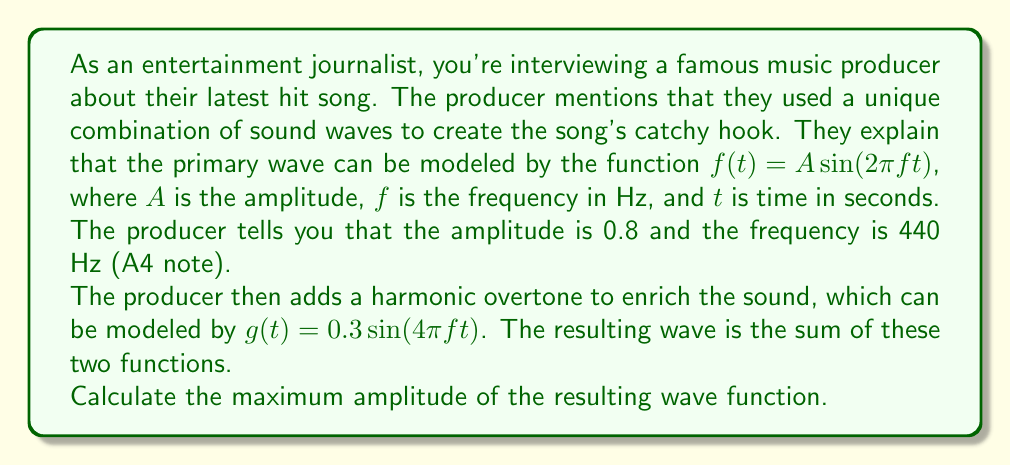Can you answer this question? To solve this problem, we need to follow these steps:

1) First, let's write out our two wave functions:
   
   $f(t) = 0.8 \sin(2\pi \cdot 440t)$
   $g(t) = 0.3 \sin(4\pi \cdot 440t)$

2) The resulting wave is the sum of these two functions:
   
   $h(t) = f(t) + g(t) = 0.8 \sin(2\pi \cdot 440t) + 0.3 \sin(4\pi \cdot 440t)$

3) To find the maximum amplitude, we need to find the maximum value of $h(t)$. This occurs when both sine functions reach their maximum value of 1 simultaneously.

4) The maximum value of $h(t)$ will be:
   
   $h_{max} = 0.8 + 0.3 = 1.1$

5) However, we need to verify if this maximum is actually achievable. To do this, we can use the trigonometric identity:

   $\sin A + \sin B = 2 \sin(\frac{A+B}{2}) \cos(\frac{A-B}{2})$

6) In our case, $A = 2\pi \cdot 440t$ and $B = 4\pi \cdot 440t$. Substituting these into the identity:

   $h(t) = 0.8 \sin(2\pi \cdot 440t) + 0.3 \sin(4\pi \cdot 440t)$
   $= 2 \cdot 0.55 \sin(3\pi \cdot 440t) \cos(-\pi \cdot 440t)$
   $= 1.1 \sin(3\pi \cdot 440t) \cos(\pi \cdot 440t)$

7) The maximum value of both sine and cosine is 1, so the maximum possible amplitude is indeed 1.1.

Therefore, the maximum amplitude of the resulting wave function is 1.1.
Answer: 1.1 